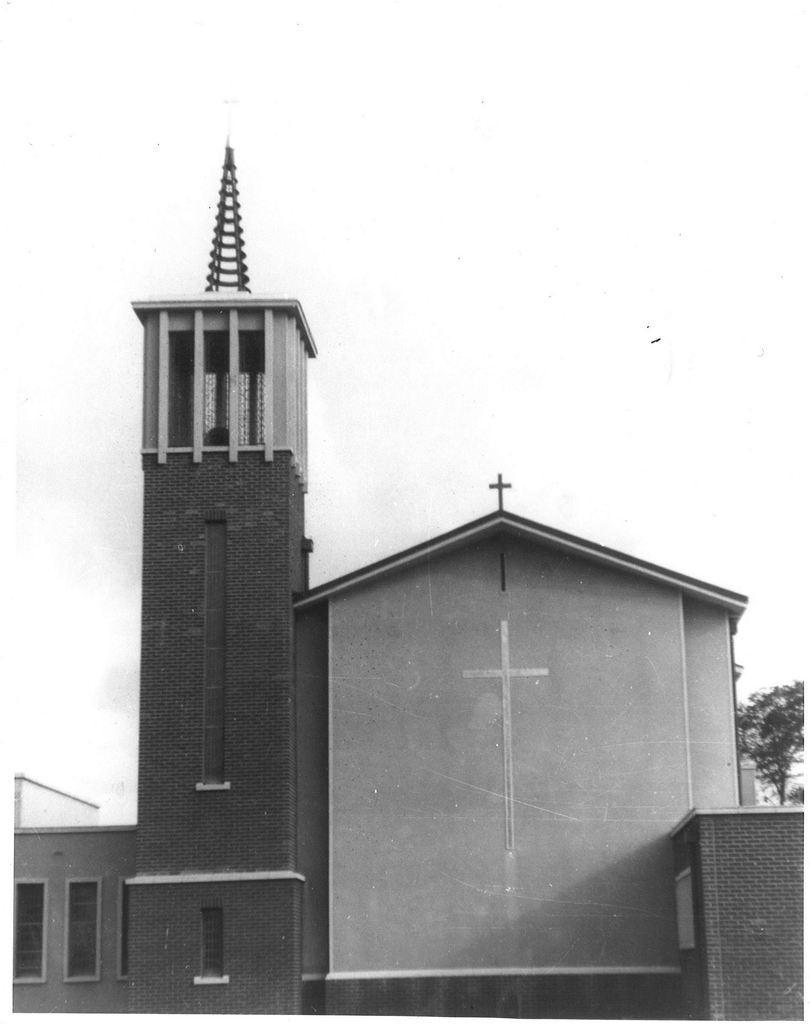Can you describe this image briefly? In this image we can see a building and windows. Above this building there is a cross symbol. Right side of the image there is a tree.  